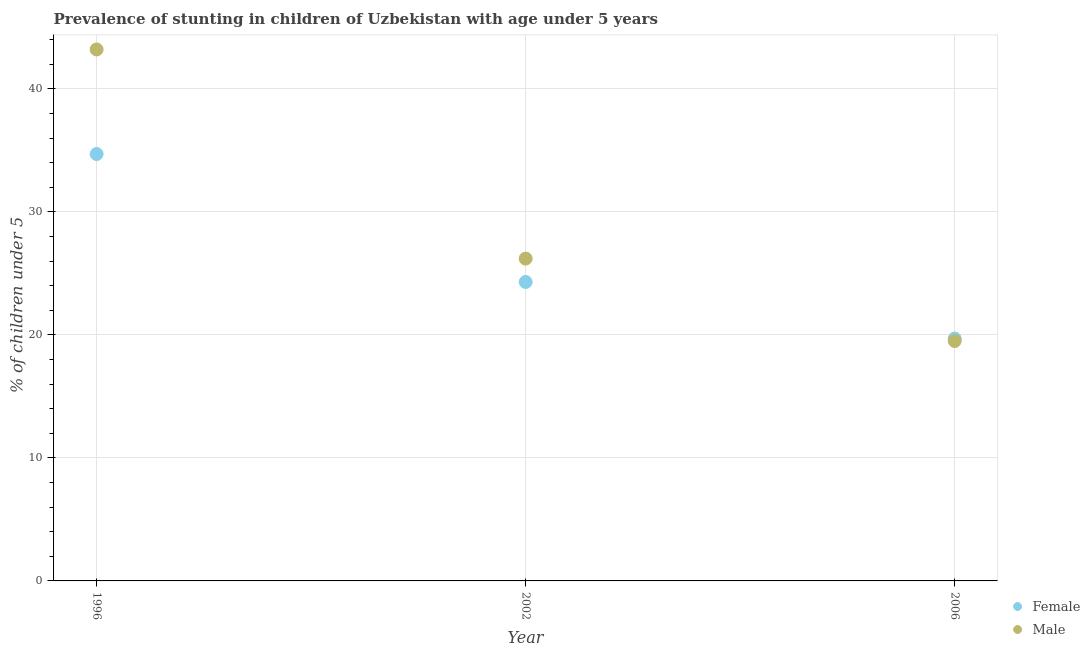How many different coloured dotlines are there?
Give a very brief answer. 2. Is the number of dotlines equal to the number of legend labels?
Provide a short and direct response. Yes. What is the percentage of stunted female children in 2002?
Your answer should be very brief. 24.3. Across all years, what is the maximum percentage of stunted female children?
Offer a very short reply. 34.7. Across all years, what is the minimum percentage of stunted female children?
Offer a terse response. 19.7. In which year was the percentage of stunted female children maximum?
Your response must be concise. 1996. What is the total percentage of stunted male children in the graph?
Your answer should be compact. 88.9. What is the difference between the percentage of stunted female children in 1996 and that in 2002?
Offer a very short reply. 10.4. What is the difference between the percentage of stunted male children in 2006 and the percentage of stunted female children in 1996?
Offer a very short reply. -15.2. What is the average percentage of stunted male children per year?
Provide a succinct answer. 29.63. What is the ratio of the percentage of stunted female children in 1996 to that in 2006?
Give a very brief answer. 1.76. Is the difference between the percentage of stunted male children in 1996 and 2002 greater than the difference between the percentage of stunted female children in 1996 and 2002?
Provide a short and direct response. Yes. What is the difference between the highest and the second highest percentage of stunted male children?
Give a very brief answer. 17. What is the difference between the highest and the lowest percentage of stunted male children?
Offer a terse response. 23.7. Is the sum of the percentage of stunted male children in 1996 and 2006 greater than the maximum percentage of stunted female children across all years?
Make the answer very short. Yes. Is the percentage of stunted female children strictly greater than the percentage of stunted male children over the years?
Give a very brief answer. No. How many years are there in the graph?
Your answer should be very brief. 3. What is the difference between two consecutive major ticks on the Y-axis?
Provide a succinct answer. 10. Where does the legend appear in the graph?
Make the answer very short. Bottom right. How many legend labels are there?
Make the answer very short. 2. How are the legend labels stacked?
Provide a succinct answer. Vertical. What is the title of the graph?
Offer a terse response. Prevalence of stunting in children of Uzbekistan with age under 5 years. Does "Electricity" appear as one of the legend labels in the graph?
Offer a very short reply. No. What is the label or title of the Y-axis?
Provide a short and direct response.  % of children under 5. What is the  % of children under 5 in Female in 1996?
Your answer should be compact. 34.7. What is the  % of children under 5 in Male in 1996?
Ensure brevity in your answer.  43.2. What is the  % of children under 5 in Female in 2002?
Your response must be concise. 24.3. What is the  % of children under 5 of Male in 2002?
Give a very brief answer. 26.2. What is the  % of children under 5 of Female in 2006?
Provide a succinct answer. 19.7. What is the  % of children under 5 in Male in 2006?
Provide a short and direct response. 19.5. Across all years, what is the maximum  % of children under 5 of Female?
Offer a very short reply. 34.7. Across all years, what is the maximum  % of children under 5 in Male?
Your answer should be compact. 43.2. Across all years, what is the minimum  % of children under 5 of Female?
Give a very brief answer. 19.7. What is the total  % of children under 5 of Female in the graph?
Give a very brief answer. 78.7. What is the total  % of children under 5 in Male in the graph?
Make the answer very short. 88.9. What is the difference between the  % of children under 5 in Male in 1996 and that in 2006?
Give a very brief answer. 23.7. What is the difference between the  % of children under 5 in Female in 1996 and the  % of children under 5 in Male in 2006?
Ensure brevity in your answer.  15.2. What is the difference between the  % of children under 5 of Female in 2002 and the  % of children under 5 of Male in 2006?
Offer a very short reply. 4.8. What is the average  % of children under 5 of Female per year?
Make the answer very short. 26.23. What is the average  % of children under 5 of Male per year?
Your response must be concise. 29.63. In the year 2002, what is the difference between the  % of children under 5 in Female and  % of children under 5 in Male?
Your answer should be very brief. -1.9. In the year 2006, what is the difference between the  % of children under 5 of Female and  % of children under 5 of Male?
Provide a succinct answer. 0.2. What is the ratio of the  % of children under 5 of Female in 1996 to that in 2002?
Give a very brief answer. 1.43. What is the ratio of the  % of children under 5 in Male in 1996 to that in 2002?
Your answer should be compact. 1.65. What is the ratio of the  % of children under 5 in Female in 1996 to that in 2006?
Provide a succinct answer. 1.76. What is the ratio of the  % of children under 5 in Male in 1996 to that in 2006?
Keep it short and to the point. 2.22. What is the ratio of the  % of children under 5 in Female in 2002 to that in 2006?
Offer a terse response. 1.23. What is the ratio of the  % of children under 5 in Male in 2002 to that in 2006?
Keep it short and to the point. 1.34. What is the difference between the highest and the lowest  % of children under 5 in Female?
Offer a very short reply. 15. What is the difference between the highest and the lowest  % of children under 5 of Male?
Your answer should be very brief. 23.7. 